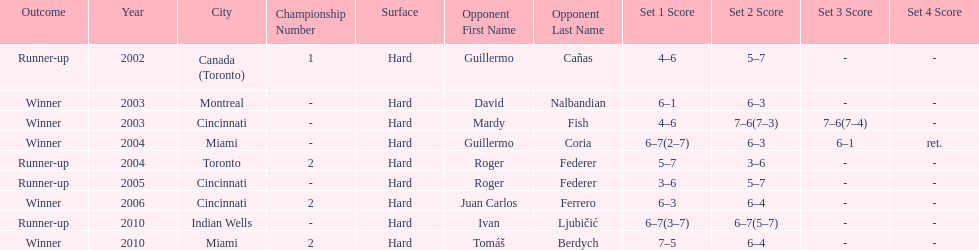How many championships occurred in toronto or montreal? 3. 